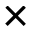Convert formula to latex. <formula><loc_0><loc_0><loc_500><loc_500>\times</formula> 